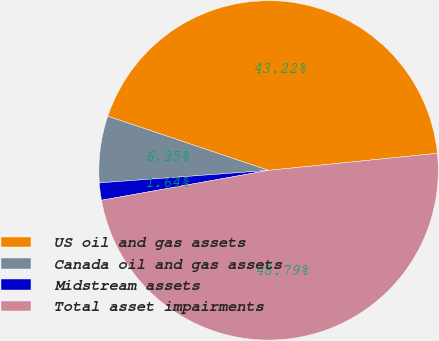Convert chart to OTSL. <chart><loc_0><loc_0><loc_500><loc_500><pie_chart><fcel>US oil and gas assets<fcel>Canada oil and gas assets<fcel>Midstream assets<fcel>Total asset impairments<nl><fcel>43.22%<fcel>6.35%<fcel>1.64%<fcel>48.79%<nl></chart> 